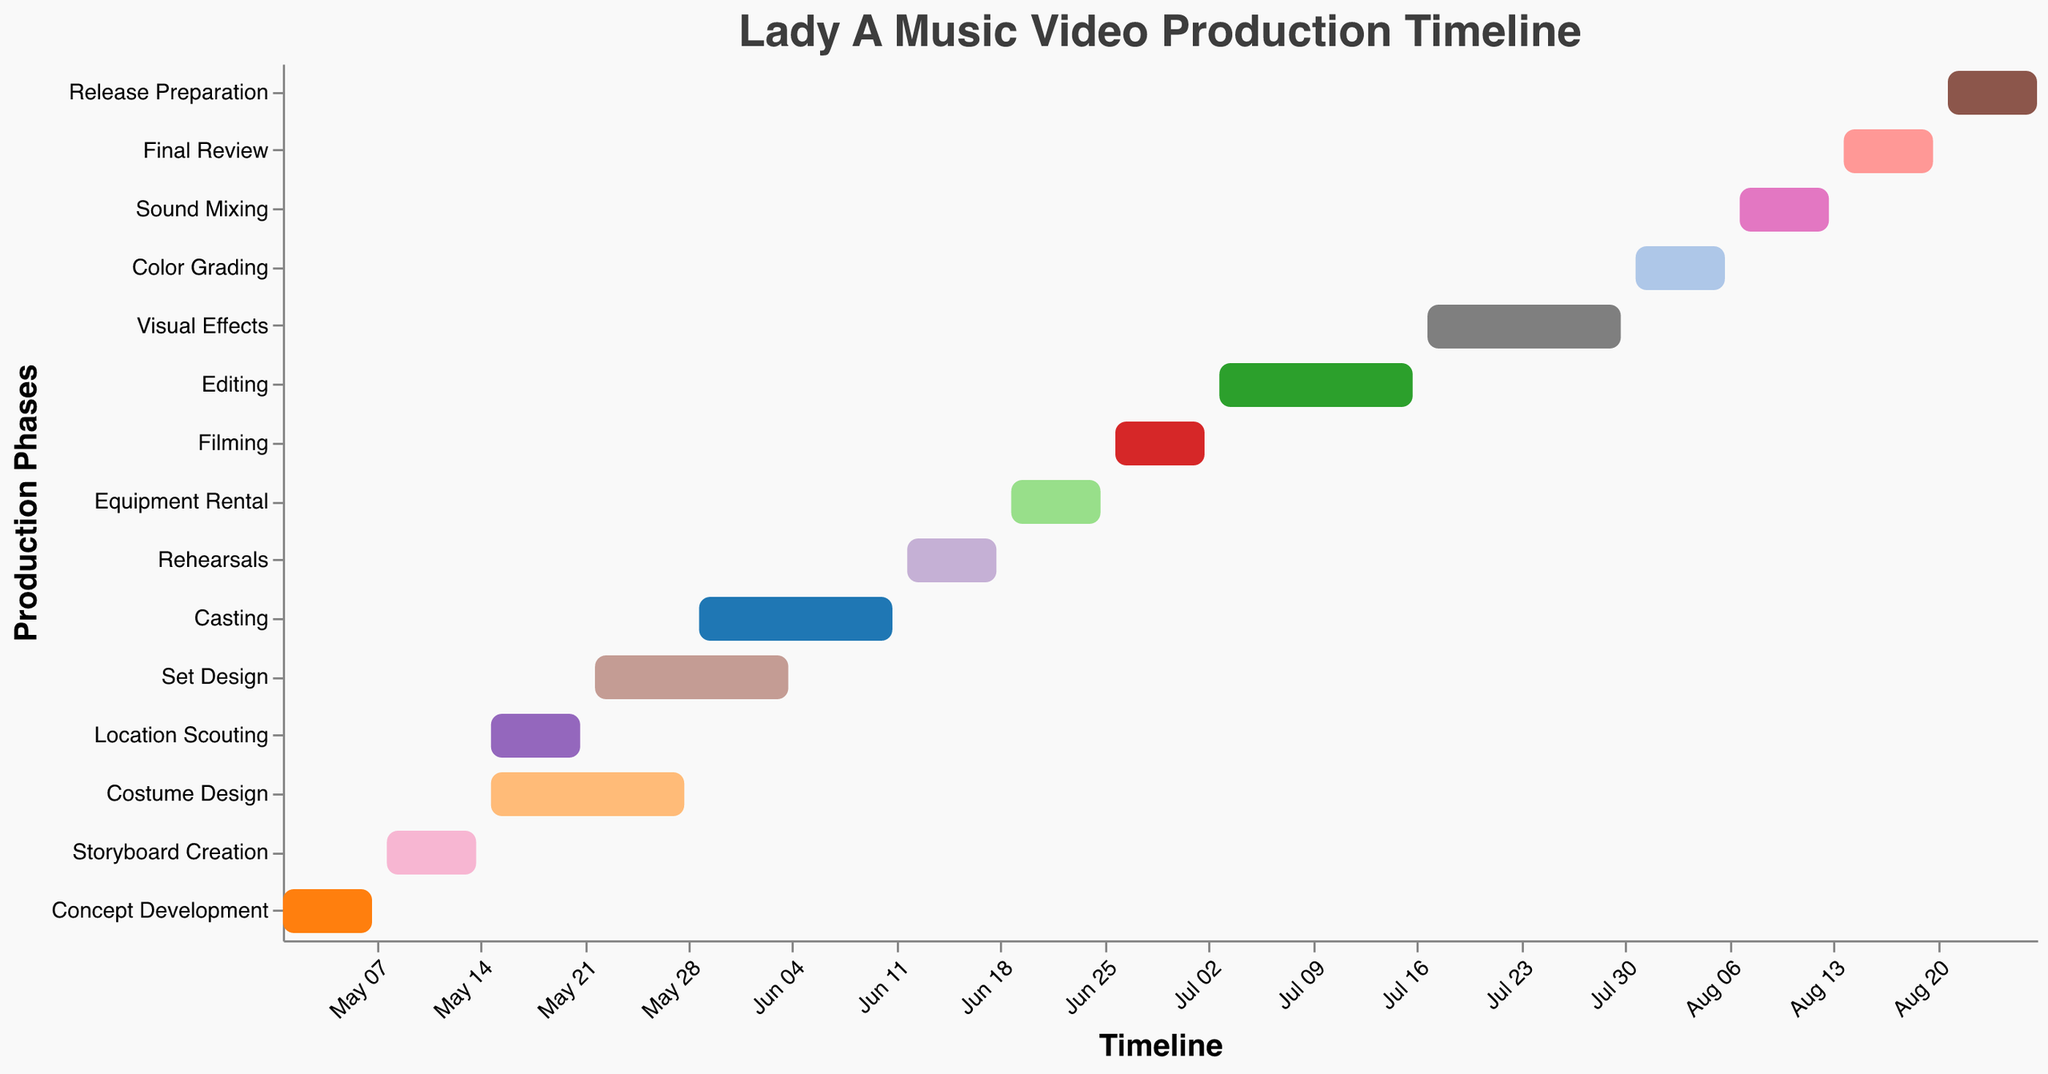What is the duration of the "Filming" phase? To determine the duration of the "Filming" phase, find the start and end dates. The "Filming" phase starts on June 26, 2023, and ends on July 2, 2023. The number of days between these dates is 7 days.
Answer: 7 days What task overlaps with the "Costume Design" phase? To identify overlapping tasks, locate the "Costume Design" phase, which runs from May 15 to May 28. The "Location Scouting" and "Set Design" tasks overlap with this period. "Location Scouting" runs from May 15 to May 21 and "Set Design" from May 22 to June 4.
Answer: Location Scouting and Set Design Which phase is the shortest in the production timeline? To find the shortest phase, compare the durations by subtracting the start date from the end date for each phase. For example, "Concept Development" runs from May 1 to May 7, which is 7 days. The step-by-step check reveals that "Rehearsals," "Color Grading," and "Sound Mixing" are shorter, each lasting 7 days.
Answer: Rehearsals, Color Grading, Sound Mixing (all 7 days) Which tasks fall into the month of July? To find tasks in July, check their start and end dates. "Filming" ends on July 2, "Editing" occurs from July 3 to July 16, "Visual Effects" from July 17 to July 30, and "Color Grading" from July 31 to August 6. So, tasks in July include "Editing" and "Visual Effects".
Answer: Editing and Visual Effects When does the final review phase occur? To determine the dates for the "Final Review" phase, locate the phase in the timeline. It starts on August 14, 2023, and ends on August 20, 2023.
Answer: August 14 to August 20, 2023 What are the main phases involved in pre-production? Pre-production phases typically include early tasks before filming. In the timeline, these tasks are "Concept Development," "Storyboard Creation," "Location Scouting," "Costume Design," "Set Design," and "Casting."
Answer: Concept Development, Storyboard Creation, Location Scouting, Costume Design, Set Design, Casting Which phase directly follows the "Filming" phase? To identify the task following "Filming," look at the timeline sequence. "Filming" ends on July 2, 2023. The task immediately following is "Editing," starting on July 3, 2023.
Answer: Editing How long is the post-production period? Post-production includes tasks from "Editing" to "Release Preparation." First, "Editing" starts on July 3 and "Release Preparation" ends on August 27, 2023. Calculate the duration between these dates: July 3 to August 27 is 56 days.
Answer: 56 days 